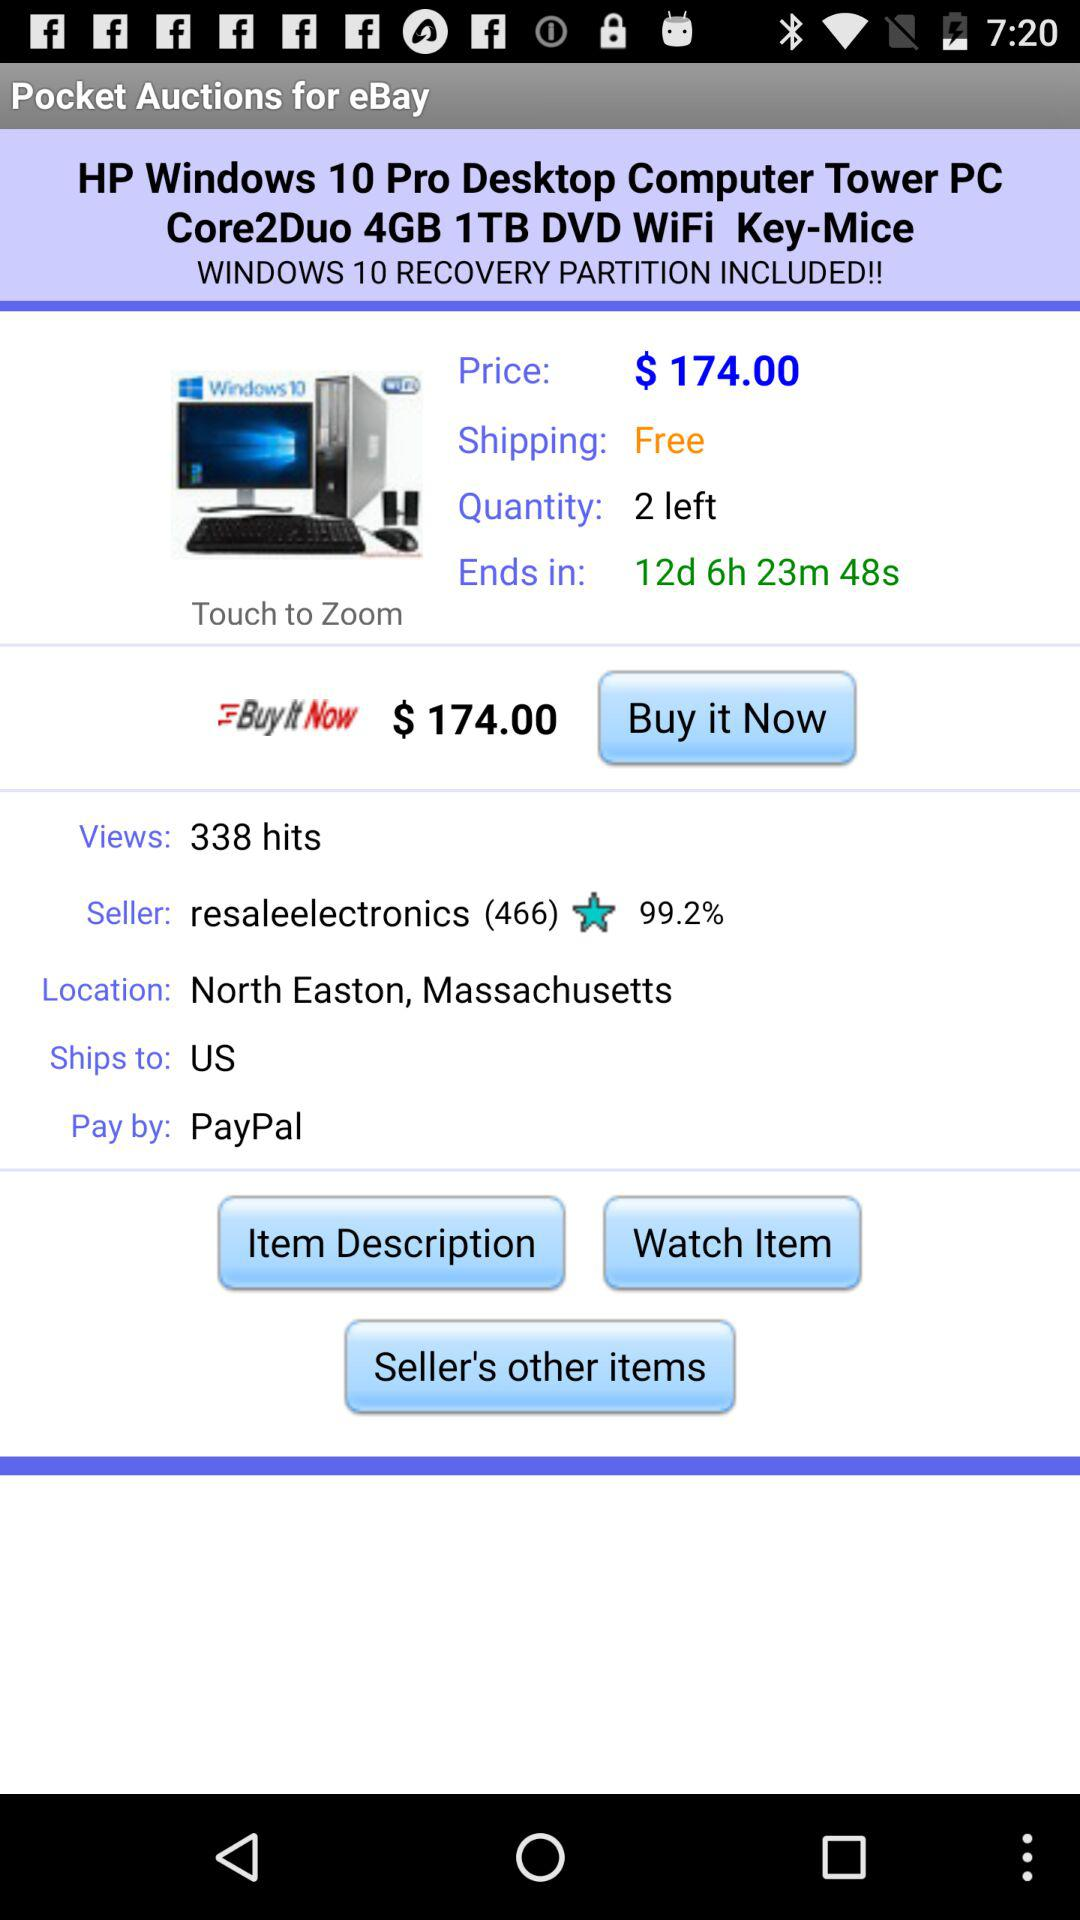How many days are left until the auction ends?
Answer the question using a single word or phrase. 12 